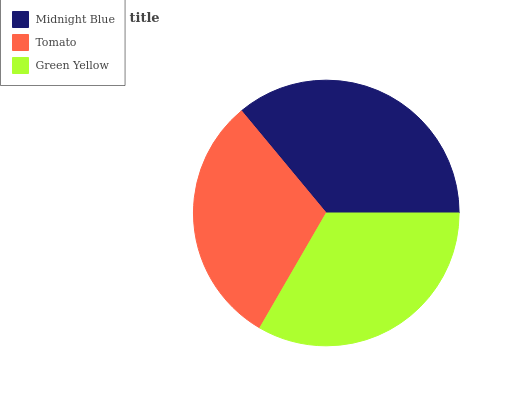Is Tomato the minimum?
Answer yes or no. Yes. Is Midnight Blue the maximum?
Answer yes or no. Yes. Is Green Yellow the minimum?
Answer yes or no. No. Is Green Yellow the maximum?
Answer yes or no. No. Is Green Yellow greater than Tomato?
Answer yes or no. Yes. Is Tomato less than Green Yellow?
Answer yes or no. Yes. Is Tomato greater than Green Yellow?
Answer yes or no. No. Is Green Yellow less than Tomato?
Answer yes or no. No. Is Green Yellow the high median?
Answer yes or no. Yes. Is Green Yellow the low median?
Answer yes or no. Yes. Is Tomato the high median?
Answer yes or no. No. Is Midnight Blue the low median?
Answer yes or no. No. 